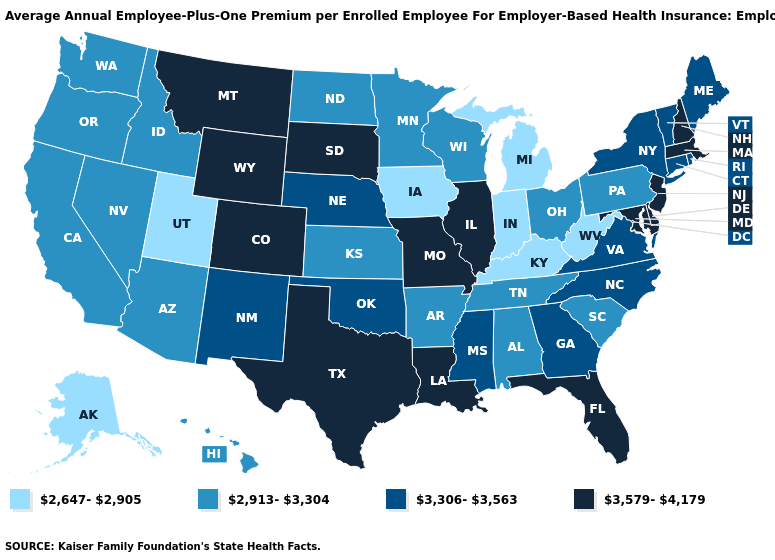How many symbols are there in the legend?
Concise answer only. 4. What is the lowest value in states that border Massachusetts?
Concise answer only. 3,306-3,563. What is the highest value in states that border North Carolina?
Be succinct. 3,306-3,563. What is the value of North Carolina?
Short answer required. 3,306-3,563. Name the states that have a value in the range 3,579-4,179?
Quick response, please. Colorado, Delaware, Florida, Illinois, Louisiana, Maryland, Massachusetts, Missouri, Montana, New Hampshire, New Jersey, South Dakota, Texas, Wyoming. How many symbols are there in the legend?
Be succinct. 4. What is the lowest value in the South?
Quick response, please. 2,647-2,905. What is the highest value in states that border Montana?
Short answer required. 3,579-4,179. Does the map have missing data?
Answer briefly. No. What is the value of Illinois?
Write a very short answer. 3,579-4,179. Name the states that have a value in the range 3,306-3,563?
Quick response, please. Connecticut, Georgia, Maine, Mississippi, Nebraska, New Mexico, New York, North Carolina, Oklahoma, Rhode Island, Vermont, Virginia. Does Pennsylvania have the same value as Ohio?
Concise answer only. Yes. Name the states that have a value in the range 2,913-3,304?
Be succinct. Alabama, Arizona, Arkansas, California, Hawaii, Idaho, Kansas, Minnesota, Nevada, North Dakota, Ohio, Oregon, Pennsylvania, South Carolina, Tennessee, Washington, Wisconsin. Name the states that have a value in the range 3,579-4,179?
Write a very short answer. Colorado, Delaware, Florida, Illinois, Louisiana, Maryland, Massachusetts, Missouri, Montana, New Hampshire, New Jersey, South Dakota, Texas, Wyoming. Does Montana have a lower value than Texas?
Write a very short answer. No. 